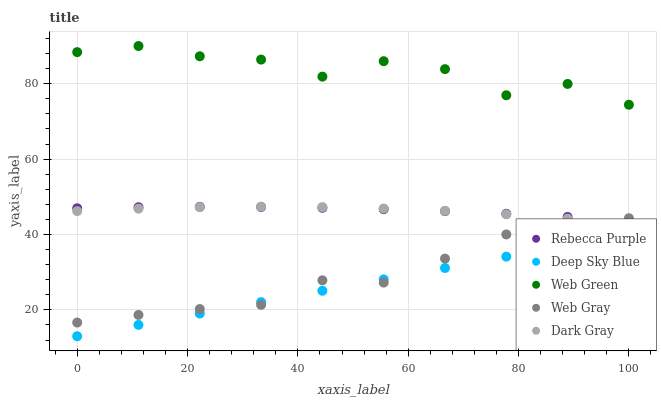Does Deep Sky Blue have the minimum area under the curve?
Answer yes or no. Yes. Does Web Green have the maximum area under the curve?
Answer yes or no. Yes. Does Web Gray have the minimum area under the curve?
Answer yes or no. No. Does Web Gray have the maximum area under the curve?
Answer yes or no. No. Is Deep Sky Blue the smoothest?
Answer yes or no. Yes. Is Web Green the roughest?
Answer yes or no. Yes. Is Web Gray the smoothest?
Answer yes or no. No. Is Web Gray the roughest?
Answer yes or no. No. Does Deep Sky Blue have the lowest value?
Answer yes or no. Yes. Does Web Gray have the lowest value?
Answer yes or no. No. Does Web Green have the highest value?
Answer yes or no. Yes. Does Web Gray have the highest value?
Answer yes or no. No. Is Deep Sky Blue less than Rebecca Purple?
Answer yes or no. Yes. Is Web Green greater than Rebecca Purple?
Answer yes or no. Yes. Does Deep Sky Blue intersect Web Gray?
Answer yes or no. Yes. Is Deep Sky Blue less than Web Gray?
Answer yes or no. No. Is Deep Sky Blue greater than Web Gray?
Answer yes or no. No. Does Deep Sky Blue intersect Rebecca Purple?
Answer yes or no. No. 